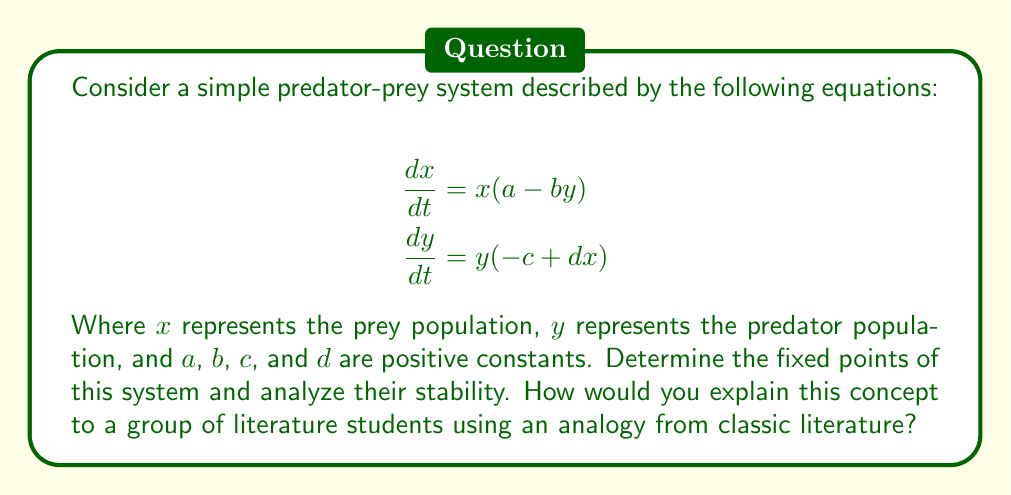Give your solution to this math problem. To analyze the stability of fixed points in this predator-prey system, we'll follow these steps:

1) Find the fixed points:
   Set $\frac{dx}{dt} = 0$ and $\frac{dy}{dt} = 0$:
   
   $x(a - by) = 0$ and $y(-c + dx) = 0$
   
   This gives us two fixed points:
   (i) $(0, 0)$
   (ii) $(\frac{c}{d}, \frac{a}{b})$

2) Linearize the system:
   Calculate the Jacobian matrix:
   
   $$J = \begin{bmatrix}
   \frac{\partial}{\partial x}(x(a-by)) & \frac{\partial}{\partial y}(x(a-by)) \\
   \frac{\partial}{\partial x}(y(-c+dx)) & \frac{\partial}{\partial y}(y(-c+dx))
   \end{bmatrix}$$
   
   $$J = \begin{bmatrix}
   a-by & -bx \\
   dy & -c+dx
   \end{bmatrix}$$

3) Evaluate the Jacobian at each fixed point:

   For $(0, 0)$:
   $$J_{(0,0)} = \begin{bmatrix}
   a & 0 \\
   0 & -c
   \end{bmatrix}$$
   
   Eigenvalues: $\lambda_1 = a$, $\lambda_2 = -c$
   
   Since $a > 0$ and $-c < 0$, this is a saddle point (unstable).

   For $(\frac{c}{d}, \frac{a}{b})$:
   $$J_{(\frac{c}{d}, \frac{a}{b})} = \begin{bmatrix}
   0 & -b\frac{c}{d} \\
   d\frac{a}{b} & 0
   \end{bmatrix}$$
   
   Eigenvalues: $\lambda = \pm i\sqrt{ac}$
   
   This is a center (neutrally stable).

4) Literary analogy:
   Explain to literature students that this system is like the relationship between Elizabeth Bennet and Mr. Darcy in Jane Austen's "Pride and Prejudice". The unstable point $(0,0)$ represents their initial meeting, where a small change in their interaction could lead to vastly different outcomes. The center point $(\frac{c}{d}, \frac{a}{b})$ represents their eventual equilibrium, where they orbit around each other in a stable relationship, neither growing apart nor collapsing together.
Answer: $(0,0)$ is an unstable saddle point; $(\frac{c}{d}, \frac{a}{b})$ is a neutrally stable center. 